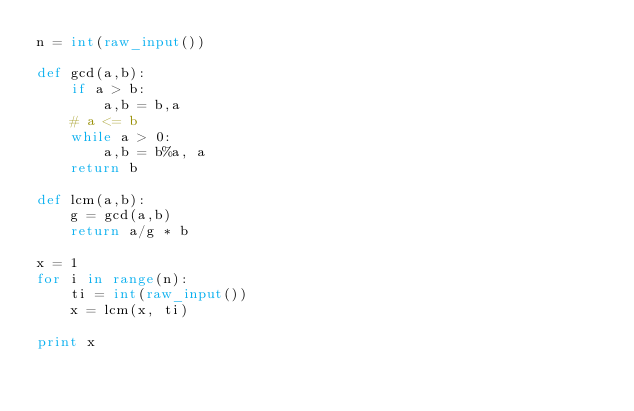Convert code to text. <code><loc_0><loc_0><loc_500><loc_500><_Python_>n = int(raw_input())

def gcd(a,b):
    if a > b:
        a,b = b,a
    # a <= b
    while a > 0:
        a,b = b%a, a
    return b

def lcm(a,b):
    g = gcd(a,b)
    return a/g * b

x = 1
for i in range(n):
    ti = int(raw_input())
    x = lcm(x, ti)

print x
</code> 